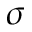<formula> <loc_0><loc_0><loc_500><loc_500>\sigma</formula> 